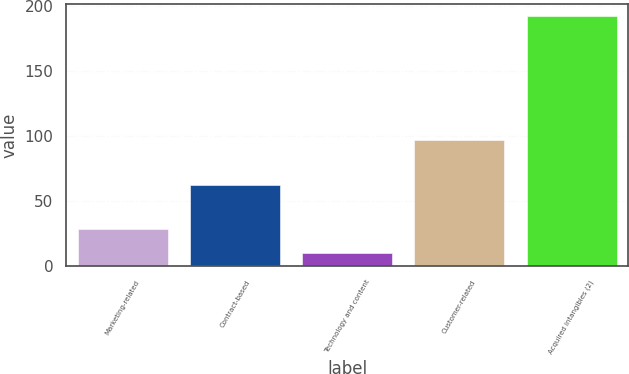Convert chart to OTSL. <chart><loc_0><loc_0><loc_500><loc_500><bar_chart><fcel>Marketing-related<fcel>Contract-based<fcel>Technology and content<fcel>Customer-related<fcel>Acquired intangibles (2)<nl><fcel>28.2<fcel>62<fcel>10<fcel>97<fcel>192<nl></chart> 